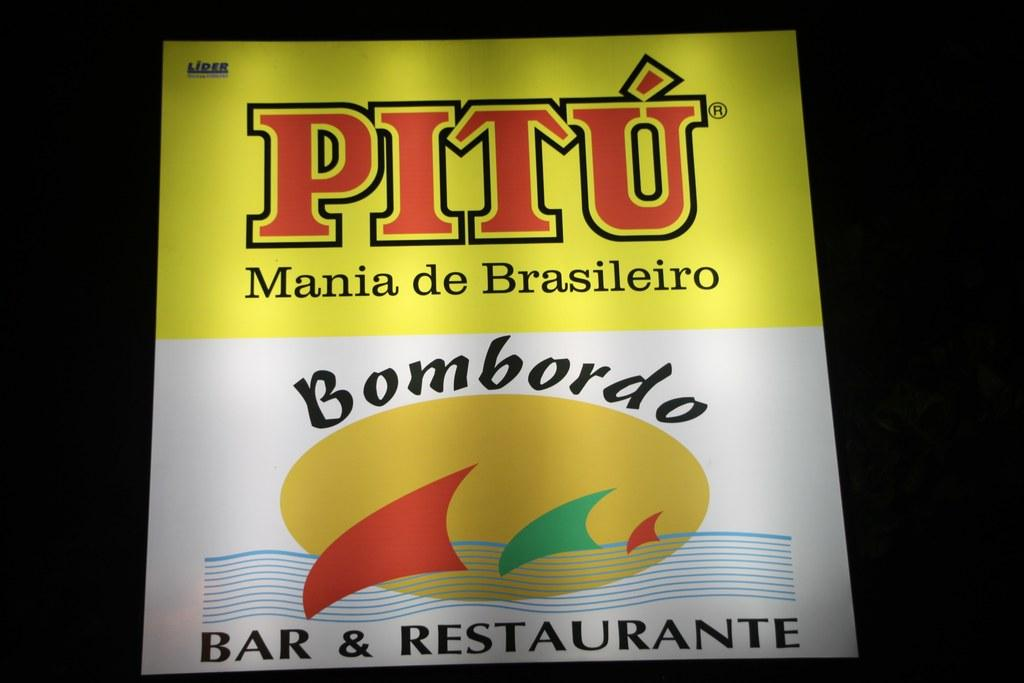What is the main object in the image? There is a poster in the image. What can be seen on the poster? There is writing on the poster. How would you describe the overall appearance of the image? The background of the image is dark. What type of trousers are being worn by the poster in the image? There is no person wearing trousers in the image; it features a poster with writing. What is the purpose of the poster in the image? The purpose of the poster cannot be determined from the image alone, as it depends on the context and content of the writing. 